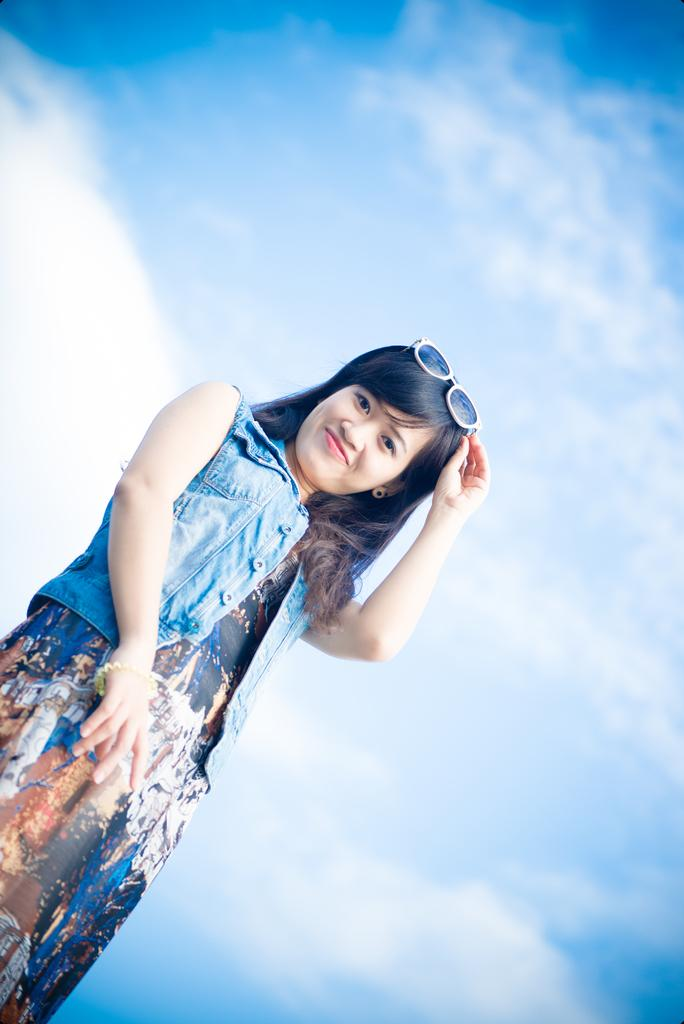Where was the image taken? The image was clicked outside. What is the main subject in the foreground of the image? There is a woman in the foreground of the image. What is the woman wearing? The woman is wearing a jacket. What expression does the woman have? The woman is smiling. What is the woman's posture in the image? The woman is standing. What can be seen in the background of the image? There is a sky visible in the background of the image. What is the weather like in the image? Clouds are present in the sky, suggesting a partly cloudy day. What color is the truck parked next to the woman in the image? There is no truck present in the image. 